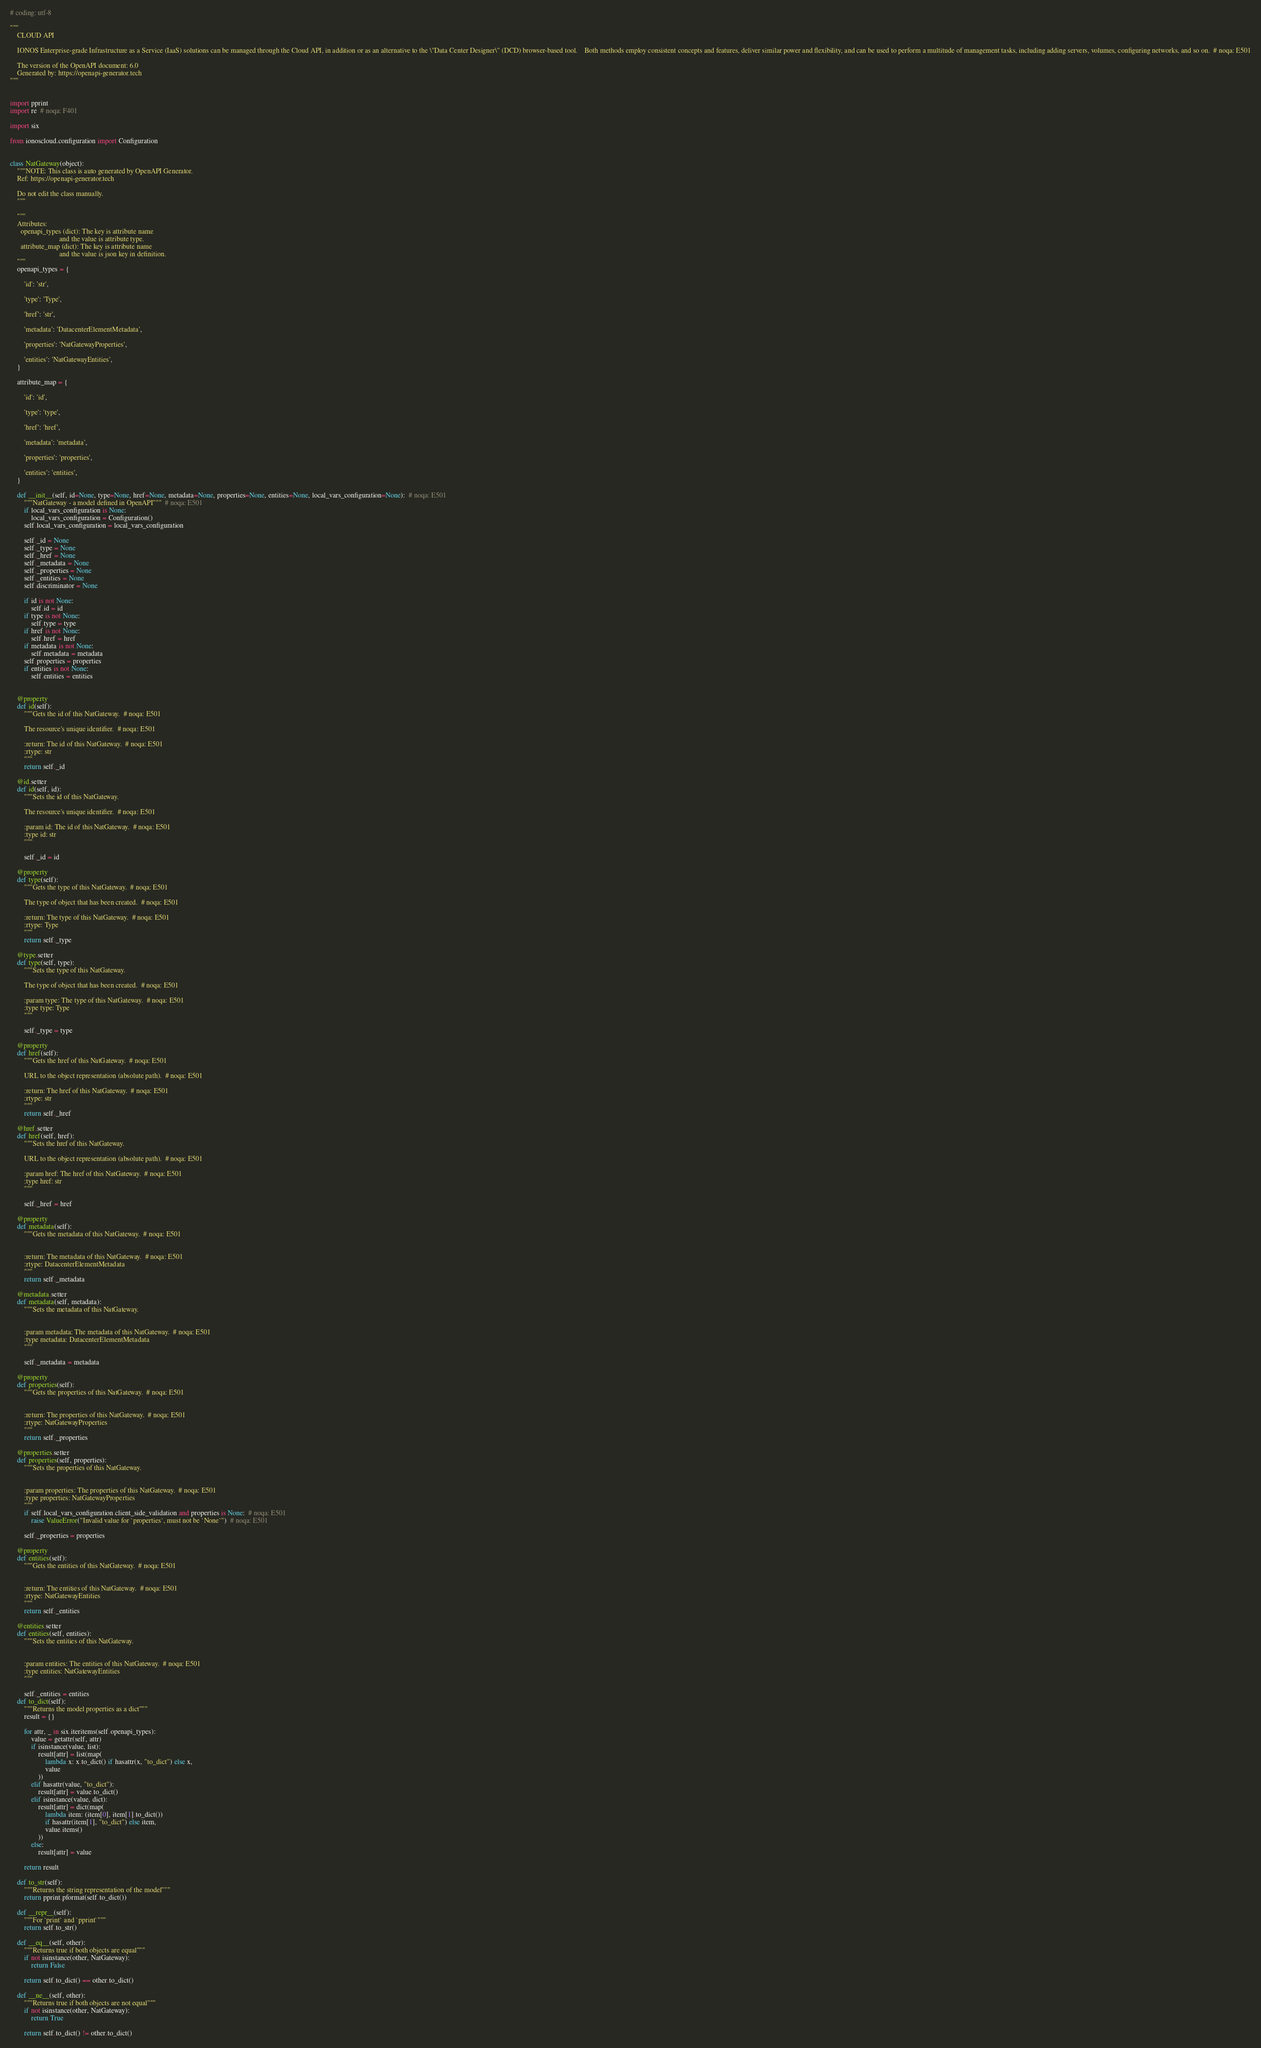<code> <loc_0><loc_0><loc_500><loc_500><_Python_># coding: utf-8

"""
    CLOUD API

    IONOS Enterprise-grade Infrastructure as a Service (IaaS) solutions can be managed through the Cloud API, in addition or as an alternative to the \"Data Center Designer\" (DCD) browser-based tool.    Both methods employ consistent concepts and features, deliver similar power and flexibility, and can be used to perform a multitude of management tasks, including adding servers, volumes, configuring networks, and so on.  # noqa: E501

    The version of the OpenAPI document: 6.0
    Generated by: https://openapi-generator.tech
"""


import pprint
import re  # noqa: F401

import six

from ionoscloud.configuration import Configuration


class NatGateway(object):
    """NOTE: This class is auto generated by OpenAPI Generator.
    Ref: https://openapi-generator.tech

    Do not edit the class manually.
    """

    """
    Attributes:
      openapi_types (dict): The key is attribute name
                            and the value is attribute type.
      attribute_map (dict): The key is attribute name
                            and the value is json key in definition.
    """
    openapi_types = {

        'id': 'str',

        'type': 'Type',

        'href': 'str',

        'metadata': 'DatacenterElementMetadata',

        'properties': 'NatGatewayProperties',

        'entities': 'NatGatewayEntities',
    }

    attribute_map = {

        'id': 'id',

        'type': 'type',

        'href': 'href',

        'metadata': 'metadata',

        'properties': 'properties',

        'entities': 'entities',
    }

    def __init__(self, id=None, type=None, href=None, metadata=None, properties=None, entities=None, local_vars_configuration=None):  # noqa: E501
        """NatGateway - a model defined in OpenAPI"""  # noqa: E501
        if local_vars_configuration is None:
            local_vars_configuration = Configuration()
        self.local_vars_configuration = local_vars_configuration

        self._id = None
        self._type = None
        self._href = None
        self._metadata = None
        self._properties = None
        self._entities = None
        self.discriminator = None

        if id is not None:
            self.id = id
        if type is not None:
            self.type = type
        if href is not None:
            self.href = href
        if metadata is not None:
            self.metadata = metadata
        self.properties = properties
        if entities is not None:
            self.entities = entities


    @property
    def id(self):
        """Gets the id of this NatGateway.  # noqa: E501

        The resource's unique identifier.  # noqa: E501

        :return: The id of this NatGateway.  # noqa: E501
        :rtype: str
        """
        return self._id

    @id.setter
    def id(self, id):
        """Sets the id of this NatGateway.

        The resource's unique identifier.  # noqa: E501

        :param id: The id of this NatGateway.  # noqa: E501
        :type id: str
        """

        self._id = id

    @property
    def type(self):
        """Gets the type of this NatGateway.  # noqa: E501

        The type of object that has been created.  # noqa: E501

        :return: The type of this NatGateway.  # noqa: E501
        :rtype: Type
        """
        return self._type

    @type.setter
    def type(self, type):
        """Sets the type of this NatGateway.

        The type of object that has been created.  # noqa: E501

        :param type: The type of this NatGateway.  # noqa: E501
        :type type: Type
        """

        self._type = type

    @property
    def href(self):
        """Gets the href of this NatGateway.  # noqa: E501

        URL to the object representation (absolute path).  # noqa: E501

        :return: The href of this NatGateway.  # noqa: E501
        :rtype: str
        """
        return self._href

    @href.setter
    def href(self, href):
        """Sets the href of this NatGateway.

        URL to the object representation (absolute path).  # noqa: E501

        :param href: The href of this NatGateway.  # noqa: E501
        :type href: str
        """

        self._href = href

    @property
    def metadata(self):
        """Gets the metadata of this NatGateway.  # noqa: E501


        :return: The metadata of this NatGateway.  # noqa: E501
        :rtype: DatacenterElementMetadata
        """
        return self._metadata

    @metadata.setter
    def metadata(self, metadata):
        """Sets the metadata of this NatGateway.


        :param metadata: The metadata of this NatGateway.  # noqa: E501
        :type metadata: DatacenterElementMetadata
        """

        self._metadata = metadata

    @property
    def properties(self):
        """Gets the properties of this NatGateway.  # noqa: E501


        :return: The properties of this NatGateway.  # noqa: E501
        :rtype: NatGatewayProperties
        """
        return self._properties

    @properties.setter
    def properties(self, properties):
        """Sets the properties of this NatGateway.


        :param properties: The properties of this NatGateway.  # noqa: E501
        :type properties: NatGatewayProperties
        """
        if self.local_vars_configuration.client_side_validation and properties is None:  # noqa: E501
            raise ValueError("Invalid value for `properties`, must not be `None`")  # noqa: E501

        self._properties = properties

    @property
    def entities(self):
        """Gets the entities of this NatGateway.  # noqa: E501


        :return: The entities of this NatGateway.  # noqa: E501
        :rtype: NatGatewayEntities
        """
        return self._entities

    @entities.setter
    def entities(self, entities):
        """Sets the entities of this NatGateway.


        :param entities: The entities of this NatGateway.  # noqa: E501
        :type entities: NatGatewayEntities
        """

        self._entities = entities
    def to_dict(self):
        """Returns the model properties as a dict"""
        result = {}

        for attr, _ in six.iteritems(self.openapi_types):
            value = getattr(self, attr)
            if isinstance(value, list):
                result[attr] = list(map(
                    lambda x: x.to_dict() if hasattr(x, "to_dict") else x,
                    value
                ))
            elif hasattr(value, "to_dict"):
                result[attr] = value.to_dict()
            elif isinstance(value, dict):
                result[attr] = dict(map(
                    lambda item: (item[0], item[1].to_dict())
                    if hasattr(item[1], "to_dict") else item,
                    value.items()
                ))
            else:
                result[attr] = value

        return result

    def to_str(self):
        """Returns the string representation of the model"""
        return pprint.pformat(self.to_dict())

    def __repr__(self):
        """For `print` and `pprint`"""
        return self.to_str()

    def __eq__(self, other):
        """Returns true if both objects are equal"""
        if not isinstance(other, NatGateway):
            return False

        return self.to_dict() == other.to_dict()

    def __ne__(self, other):
        """Returns true if both objects are not equal"""
        if not isinstance(other, NatGateway):
            return True

        return self.to_dict() != other.to_dict()
</code> 